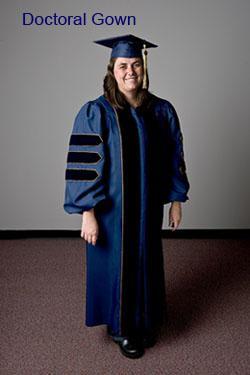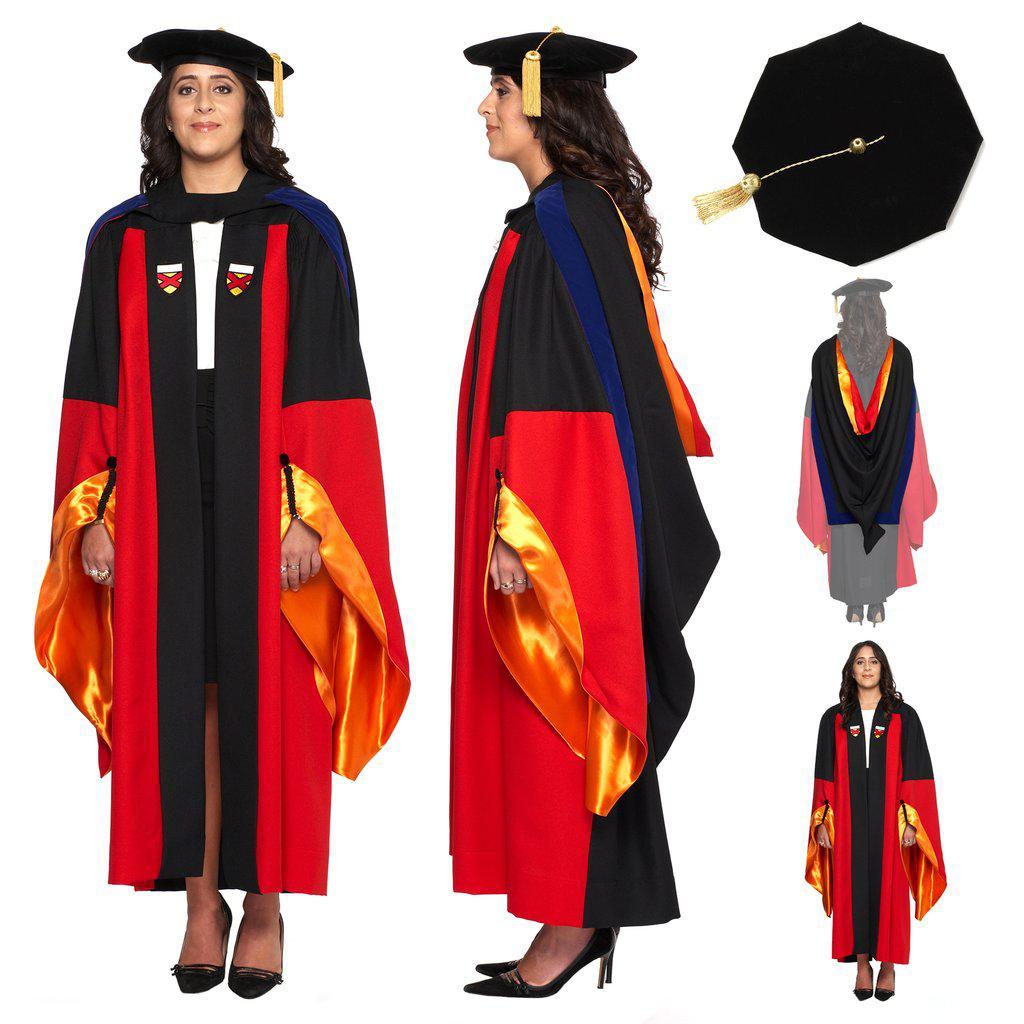The first image is the image on the left, the second image is the image on the right. Given the left and right images, does the statement "A graduation gown option includes a short red scarf that stops at the waist." hold true? Answer yes or no. No. 